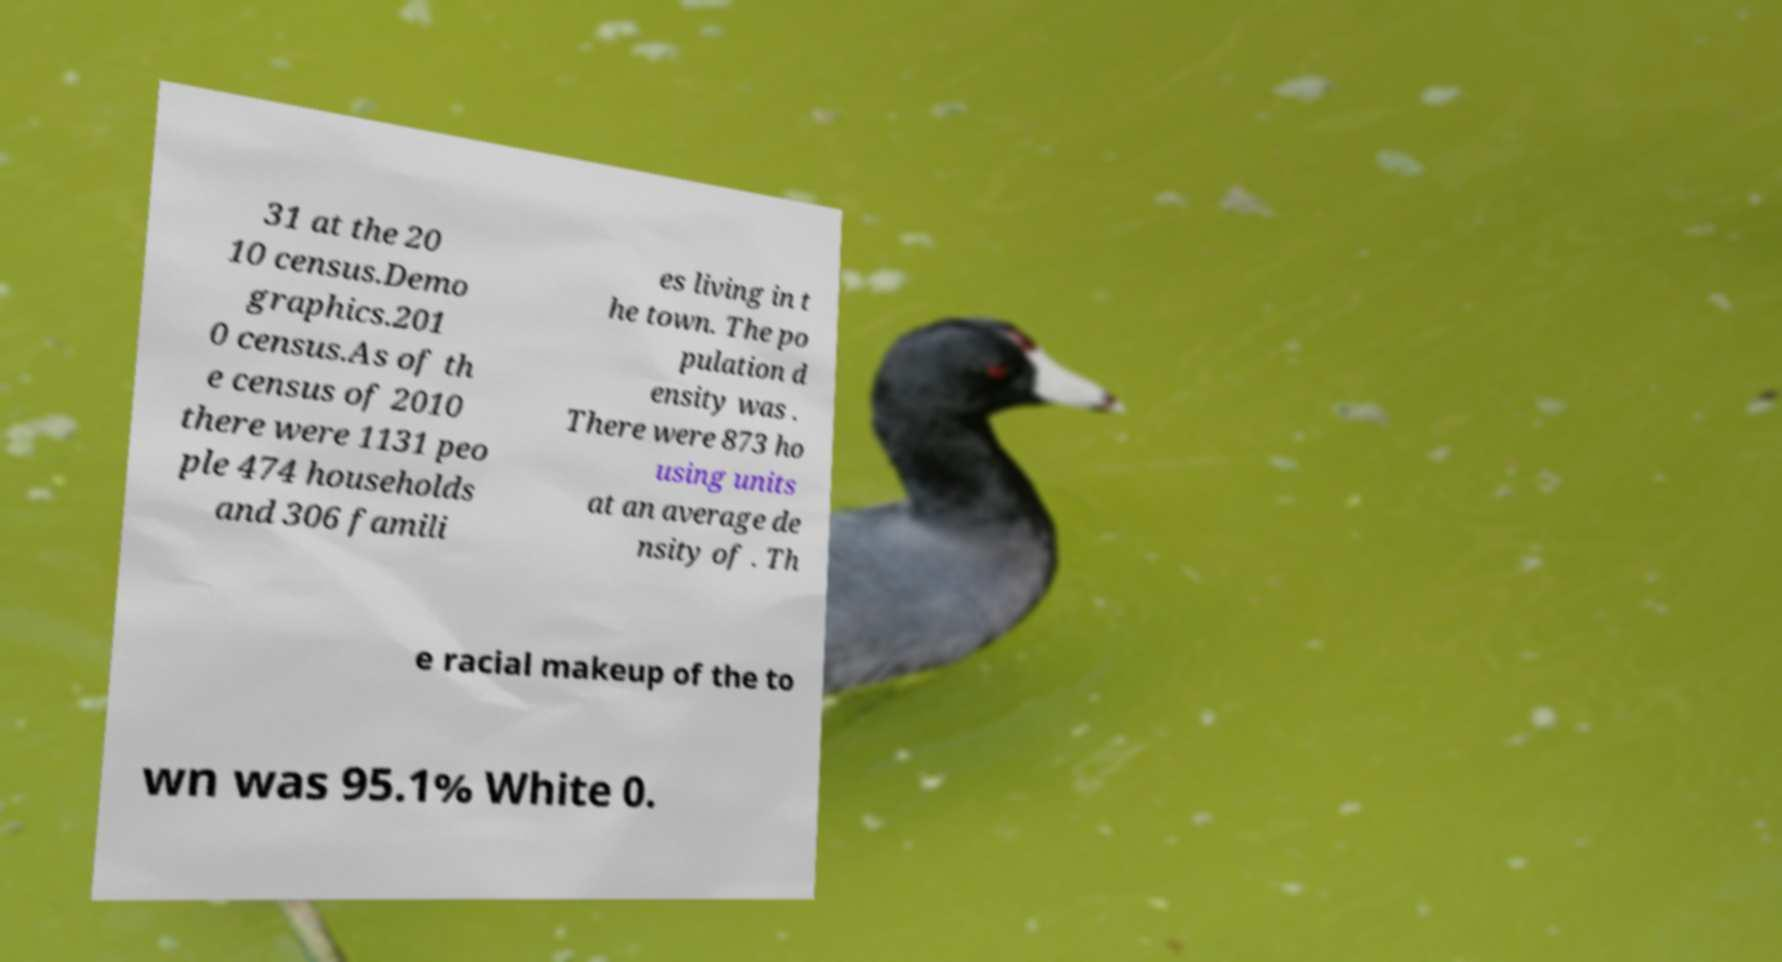Please identify and transcribe the text found in this image. 31 at the 20 10 census.Demo graphics.201 0 census.As of th e census of 2010 there were 1131 peo ple 474 households and 306 famili es living in t he town. The po pulation d ensity was . There were 873 ho using units at an average de nsity of . Th e racial makeup of the to wn was 95.1% White 0. 